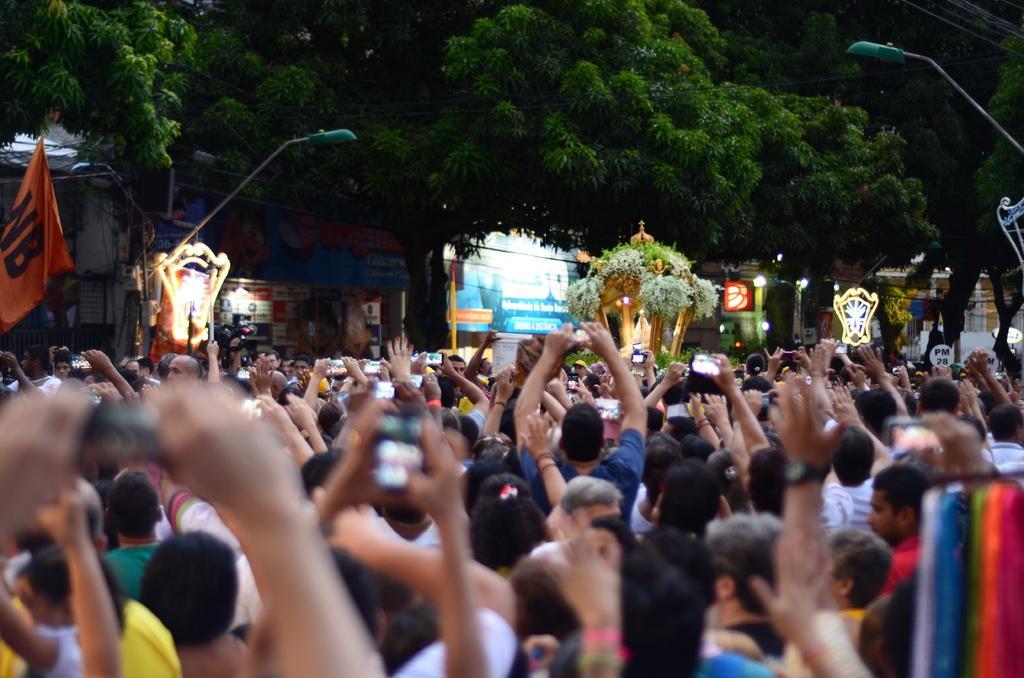Describe this image in one or two sentences. In this image we can see some people on the street and among them few people holding mobile phones in their hands. We can see few buildings which looks like stores and there are some other objects and we can see few trees and street lights. 